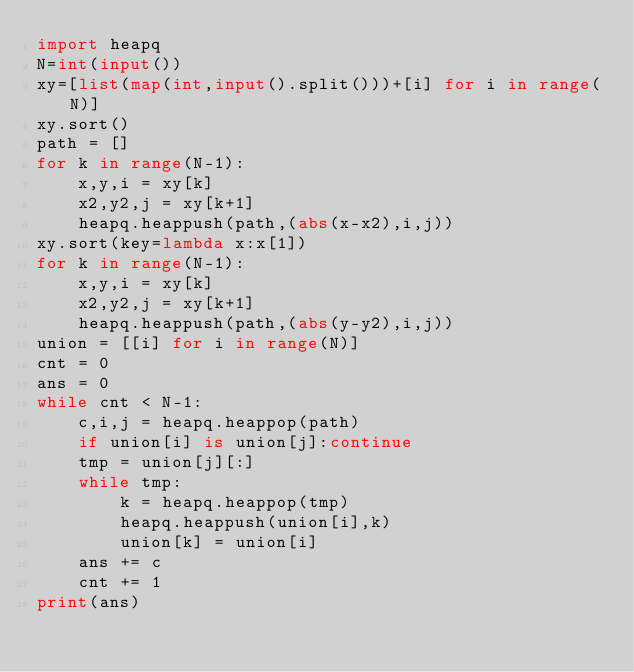Convert code to text. <code><loc_0><loc_0><loc_500><loc_500><_Python_>import heapq
N=int(input())
xy=[list(map(int,input().split()))+[i] for i in range(N)]
xy.sort()
path = []
for k in range(N-1):
    x,y,i = xy[k]
    x2,y2,j = xy[k+1]
    heapq.heappush(path,(abs(x-x2),i,j))
xy.sort(key=lambda x:x[1])
for k in range(N-1):
    x,y,i = xy[k]
    x2,y2,j = xy[k+1]
    heapq.heappush(path,(abs(y-y2),i,j))
union = [[i] for i in range(N)]
cnt = 0
ans = 0
while cnt < N-1:
    c,i,j = heapq.heappop(path)
    if union[i] is union[j]:continue
    tmp = union[j][:]
    while tmp:
        k = heapq.heappop(tmp)
        heapq.heappush(union[i],k)
        union[k] = union[i]
    ans += c
    cnt += 1
print(ans)</code> 